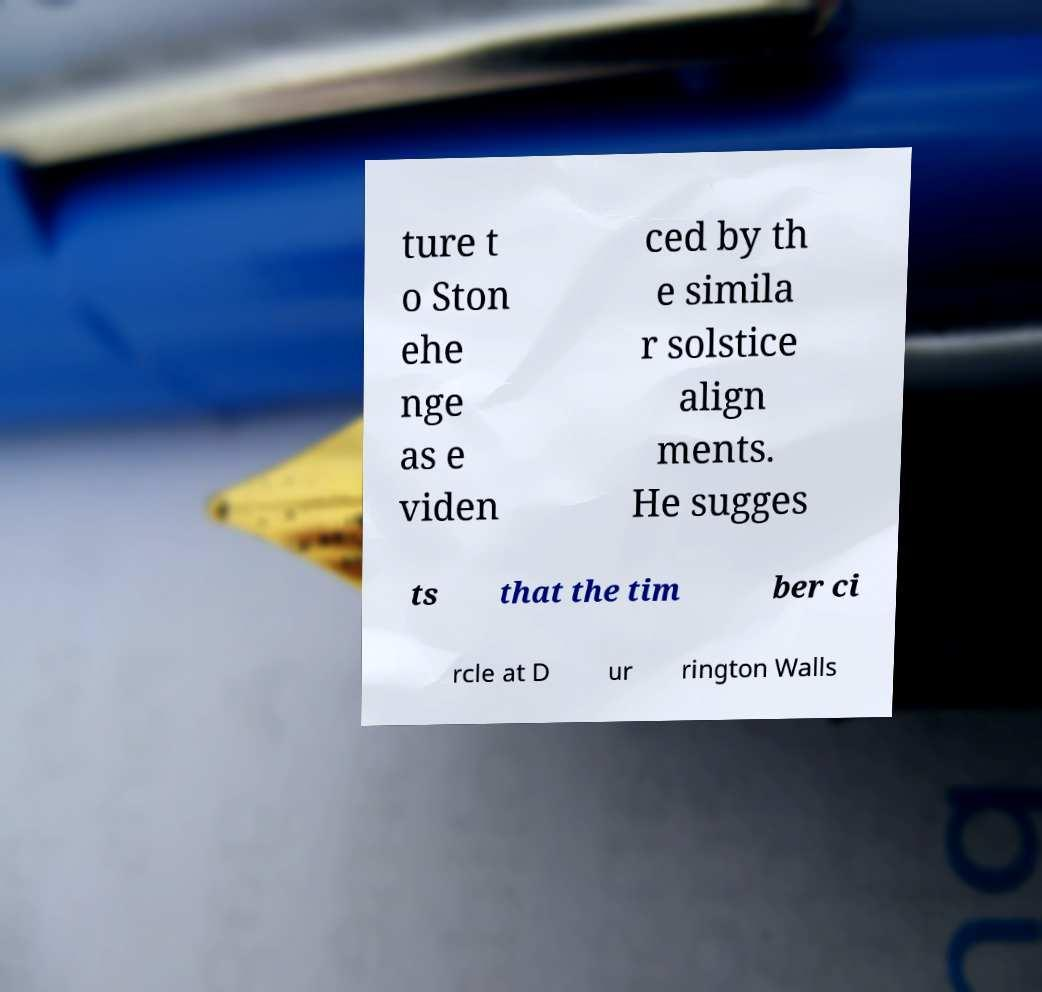Could you assist in decoding the text presented in this image and type it out clearly? ture t o Ston ehe nge as e viden ced by th e simila r solstice align ments. He sugges ts that the tim ber ci rcle at D ur rington Walls 